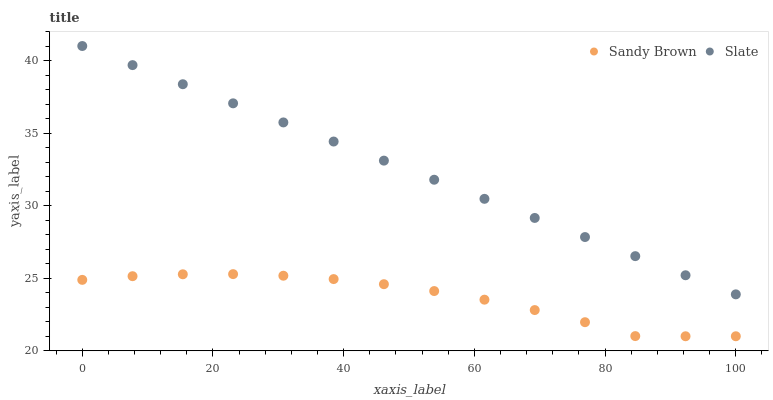Does Sandy Brown have the minimum area under the curve?
Answer yes or no. Yes. Does Slate have the maximum area under the curve?
Answer yes or no. Yes. Does Sandy Brown have the maximum area under the curve?
Answer yes or no. No. Is Slate the smoothest?
Answer yes or no. Yes. Is Sandy Brown the roughest?
Answer yes or no. Yes. Is Sandy Brown the smoothest?
Answer yes or no. No. Does Sandy Brown have the lowest value?
Answer yes or no. Yes. Does Slate have the highest value?
Answer yes or no. Yes. Does Sandy Brown have the highest value?
Answer yes or no. No. Is Sandy Brown less than Slate?
Answer yes or no. Yes. Is Slate greater than Sandy Brown?
Answer yes or no. Yes. Does Sandy Brown intersect Slate?
Answer yes or no. No. 